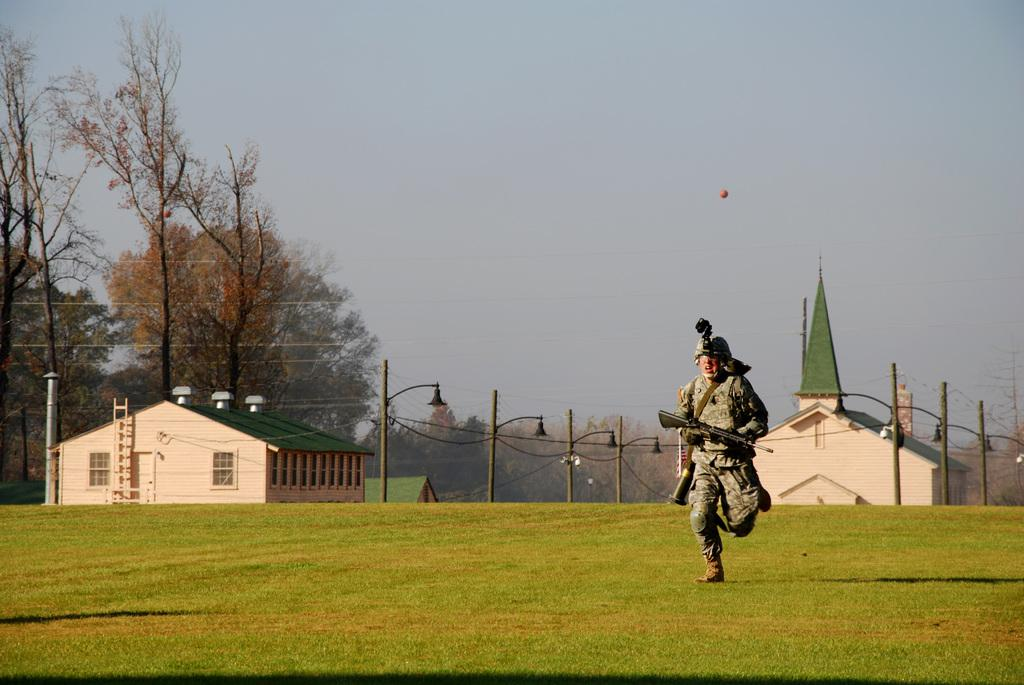What is the man in the image wearing? The man is wearing an army dress in the image. What is the man holding in the image? The man is holding a weapon in the image. What is the man doing in the image? The man is running in the ground in the image. What type of clothing can be seen in the image besides the army dress? There are shirts in the image. What can be seen on the left side of the image? There are trees on the left side of the image. What is visible at the top of the image? The sky is visible at the top of the image. What is the condition of the nail in the image? There is no nail present in the image. 